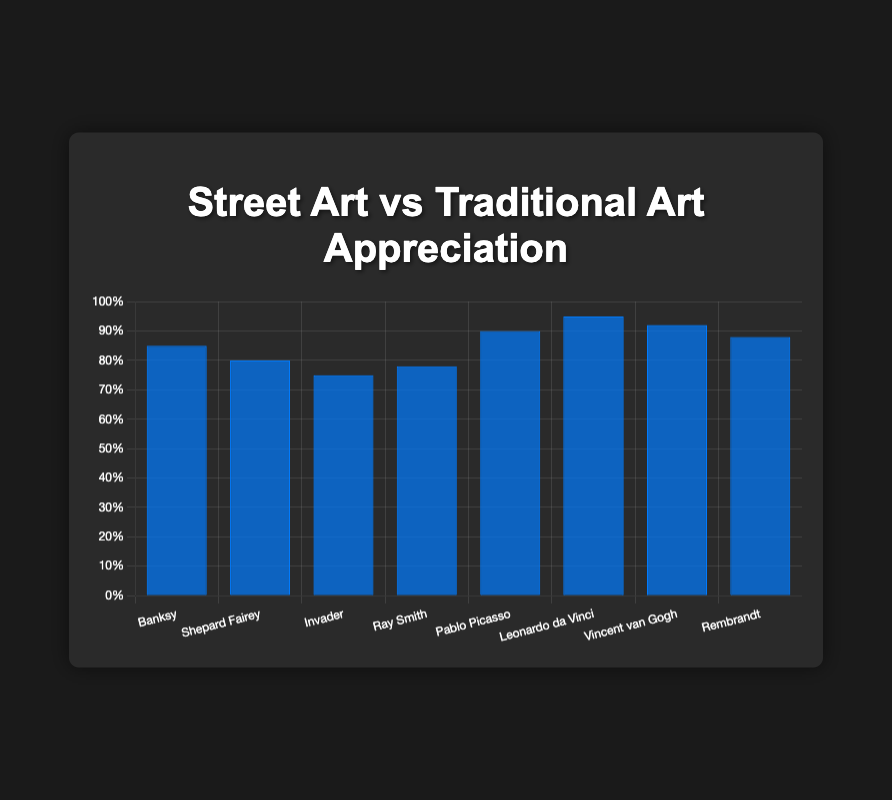What's the highest appreciation level among street artists? The highest appreciation level among street artists is found by looking at the tallest blue bar within the street art category. Banksy, Shepard Fairey, Invader, and Ray Smith fall under this category. Banksy has the highest appreciation level at 85%.
Answer: 85 Which artist has a higher average appreciation level, Banksy or Shepard Fairey? Compare the blue bars of Banksy and Shepard Fairey. Banksy's appreciation level is 85%, while Shepard Fairey's is 80%. Hence, Banksy's appreciation level is higher.
Answer: Banksy What’s the difference in appreciation levels between Ray Smith and Banksy? The blue bar for Ray Smith indicates an appreciation level of 78%, and for Banksy, it’s 85%. Subtract Ray Smith's level from Banksy’s to find the difference: 85% - 78% = 7%.
Answer: 7% Which category has the artist with the highest appreciation level? Among the blue bars, Leonardo da Vinci, a traditional artist, has the highest appreciation level at 95%.
Answer: Traditional Art What's the average appreciation level of traditional artists? Sum the appreciation levels of traditional artists: (90+95+92+88) and then divide by the number of artists (4). (90+95+92+88)/4 is 91.25%.
Answer: 91.25% Compare the average appreciation levels of street art and traditional art categories. Which category has a higher average? Calculate the average for each category: Street Art: (85+80+75+78)/4 = 79.5%. Traditional Art: (90+95+92+88)/4 = 91.25%. Traditional Art has a higher average appreciation level.
Answer: Traditional Art How does Ray Smith's appreciation level compare to the overall average appreciation level of street artists? The average appreciation level of street artists is (85+80+75+78)/4 = 79.5%. Ray Smith’s appreciation level is 78%, which is slightly below the average.
Answer: Below What’s the combined appreciation level for Pablo Picasso and Vincent van Gogh? Sum the levels for Pablo Picasso (90%) and Vincent van Gogh (92%): 90% + 92% = 182%.
Answer: 182 If the average appreciation level of Invader increased by 10%, how would it compare to Shepard Fairey’s current level? Invader’s current level is 75%; increasing this by 10% results in 85%, which is higher than Shepard Fairey’s level of 80%.
Answer: Higher 